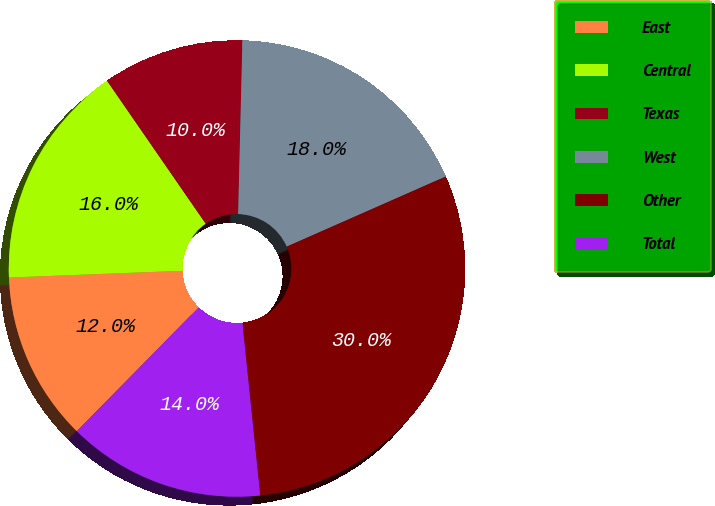Convert chart to OTSL. <chart><loc_0><loc_0><loc_500><loc_500><pie_chart><fcel>East<fcel>Central<fcel>Texas<fcel>West<fcel>Other<fcel>Total<nl><fcel>12.01%<fcel>16.0%<fcel>10.01%<fcel>18.0%<fcel>29.97%<fcel>14.01%<nl></chart> 